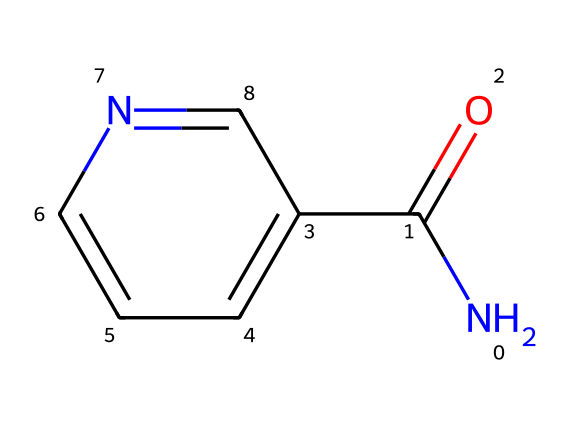What is the molecular formula of niacinamide? To determine the molecular formula, we analyze the SMILES representation. Counting the elements: there are 6 carbon atoms, 6 hydrogen atoms, 1 nitrogen atom, and 1 oxygen atom, which gives us a formula of C6H6N2O.
Answer: C6H6N2O How many nitrogen atoms are present in niacinamide? By examining the SMILES, we see one nitrogen atom (N) attached to the carbon. This gives us the total count of nitrogen atoms.
Answer: 1 What type of chemical compound is niacinamide classified as? Niacinamide, based on its nitrogen and carbon structure, falls under the category of an amide (due to the presence of the carbonyl group adjacent to a nitrogen atom), which is characteristic of these types of compounds.
Answer: amide What structural feature indicates that niacinamide can potentially improve skin brightness? Niacinamide contains a carbonyl (C=O) group and a nitrogen atom, which indicates that it can potentially enhance skin brightness due to its ability to affect cellular signaling and reduce pigmentation.
Answer: carbonyl group What is the hybridization of the nitrogen atom in niacinamide? The nitrogen atom is bonded to a carbonyl carbon and is likely involved in a resonance structure with the carbon's double bond; hence its hybridization is sp2.
Answer: sp2 How does the presence of the aromatic ring influence the properties of niacinamide? The aromatic ring offers stability and can enhance the absorption and effectiveness of niacinamide on the skin, contributing to its brightening effects.
Answer: stability and absorption 